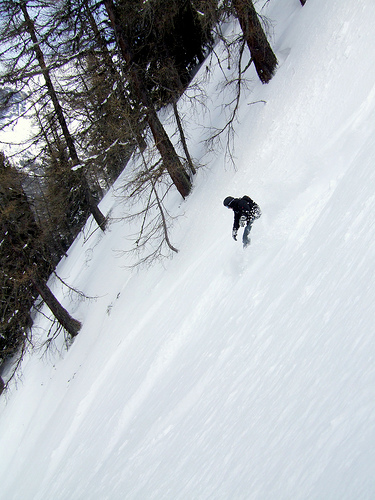<image>
Is the tree to the right of the men? Yes. From this viewpoint, the tree is positioned to the right side relative to the men. Where is the tree in relation to the snow? Is it next to the snow? No. The tree is not positioned next to the snow. They are located in different areas of the scene. 